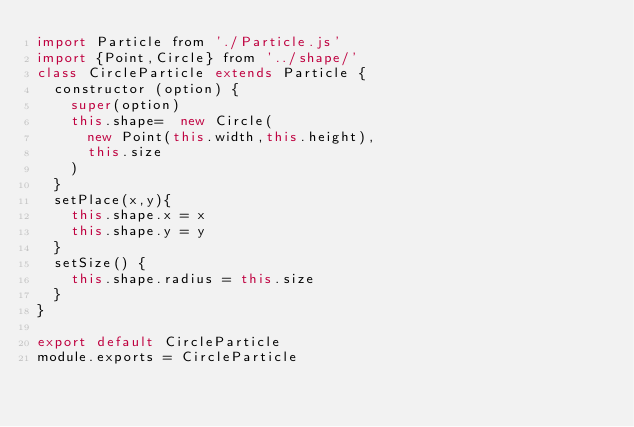Convert code to text. <code><loc_0><loc_0><loc_500><loc_500><_JavaScript_>import Particle from './Particle.js'
import {Point,Circle} from '../shape/'
class CircleParticle extends Particle {
  constructor (option) {
    super(option)
    this.shape=  new Circle(
      new Point(this.width,this.height),
      this.size
    )
  }
  setPlace(x,y){
    this.shape.x = x
    this.shape.y = y
  } 
  setSize() {
    this.shape.radius = this.size
  }
}

export default CircleParticle
module.exports = CircleParticle</code> 